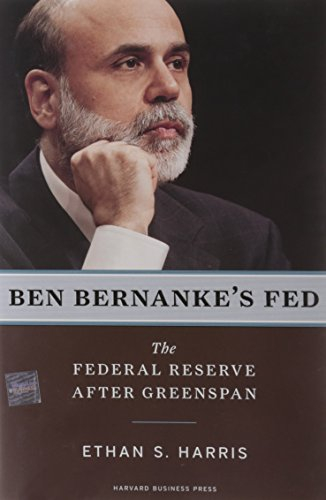What is the title of this book? The book's title is 'Ben Bernanke's Fed: The Federal Reserve After Greenspan,' which provides insight into Ben Bernanke's tenure at the Federal Reserve following Alan Greenspan's leadership. 